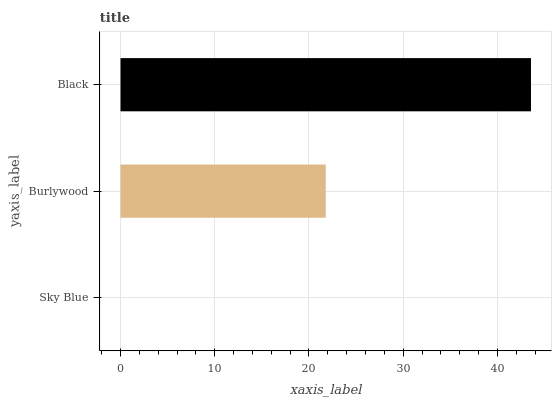Is Sky Blue the minimum?
Answer yes or no. Yes. Is Black the maximum?
Answer yes or no. Yes. Is Burlywood the minimum?
Answer yes or no. No. Is Burlywood the maximum?
Answer yes or no. No. Is Burlywood greater than Sky Blue?
Answer yes or no. Yes. Is Sky Blue less than Burlywood?
Answer yes or no. Yes. Is Sky Blue greater than Burlywood?
Answer yes or no. No. Is Burlywood less than Sky Blue?
Answer yes or no. No. Is Burlywood the high median?
Answer yes or no. Yes. Is Burlywood the low median?
Answer yes or no. Yes. Is Sky Blue the high median?
Answer yes or no. No. Is Black the low median?
Answer yes or no. No. 